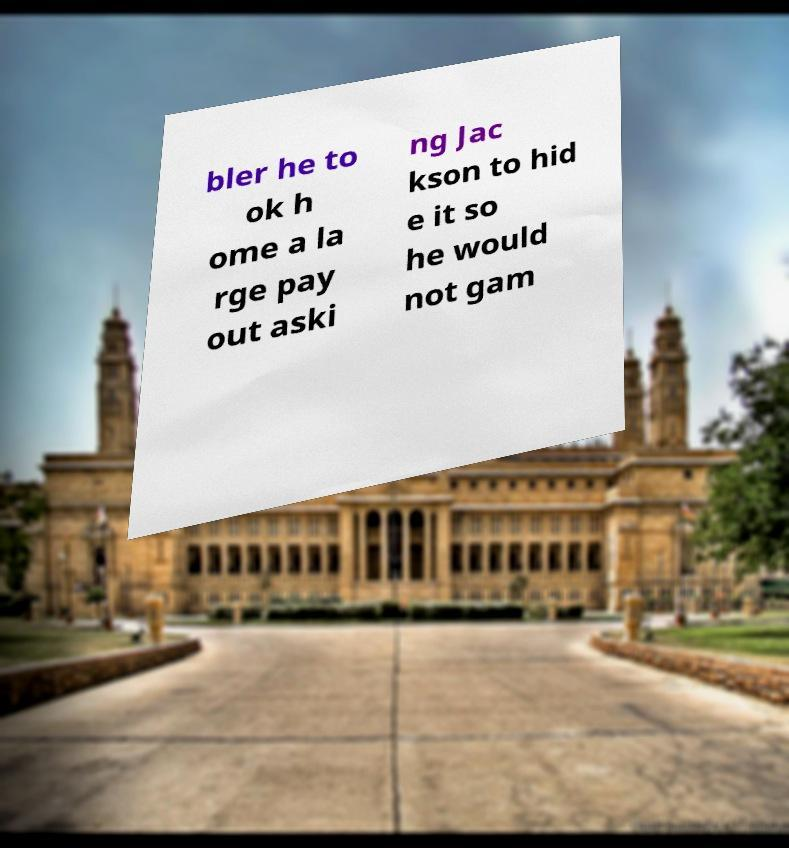Could you assist in decoding the text presented in this image and type it out clearly? bler he to ok h ome a la rge pay out aski ng Jac kson to hid e it so he would not gam 